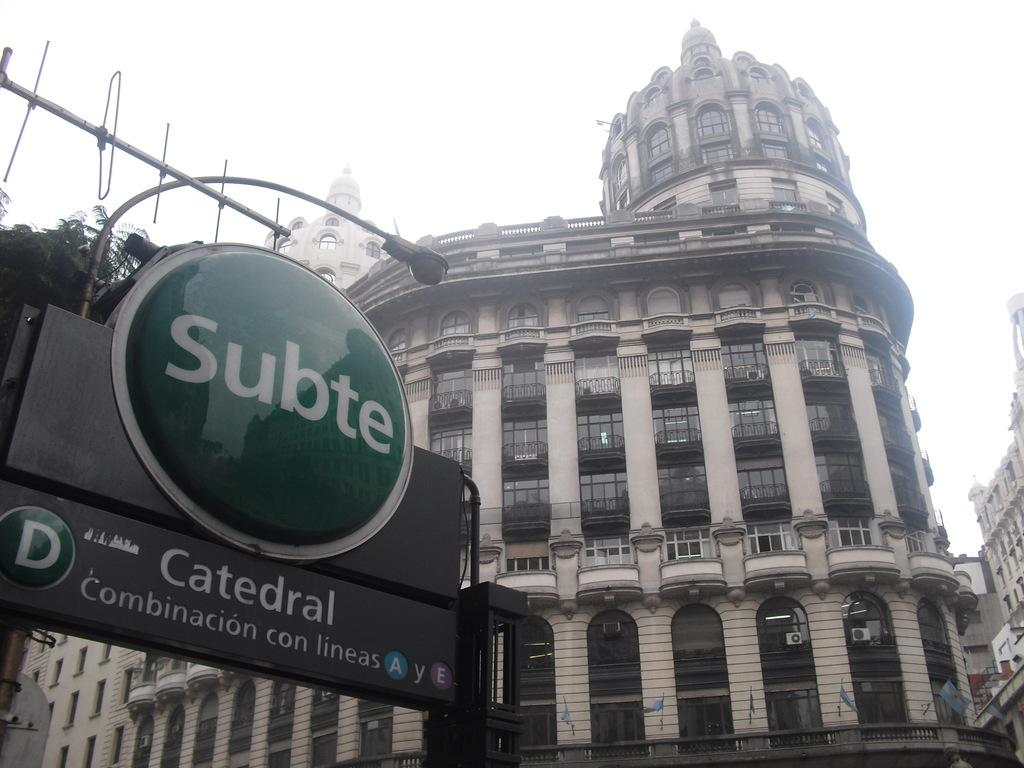What can be found on the left side of the image? There are sign boards and a light attached to a pole on the left side of the image. What type of structures are visible in the background of the image? There are buildings with windows in the background of the image. What is visible in the sky in the image? The sky is visible in the background of the image. What type of snake can be seen slithering on the sign boards in the image? There is no snake present in the image; the image only features sign boards and a light attached to a pole. What substance is being exchanged between the buildings in the image? There is no indication of any substance exchange between the buildings in the image. 